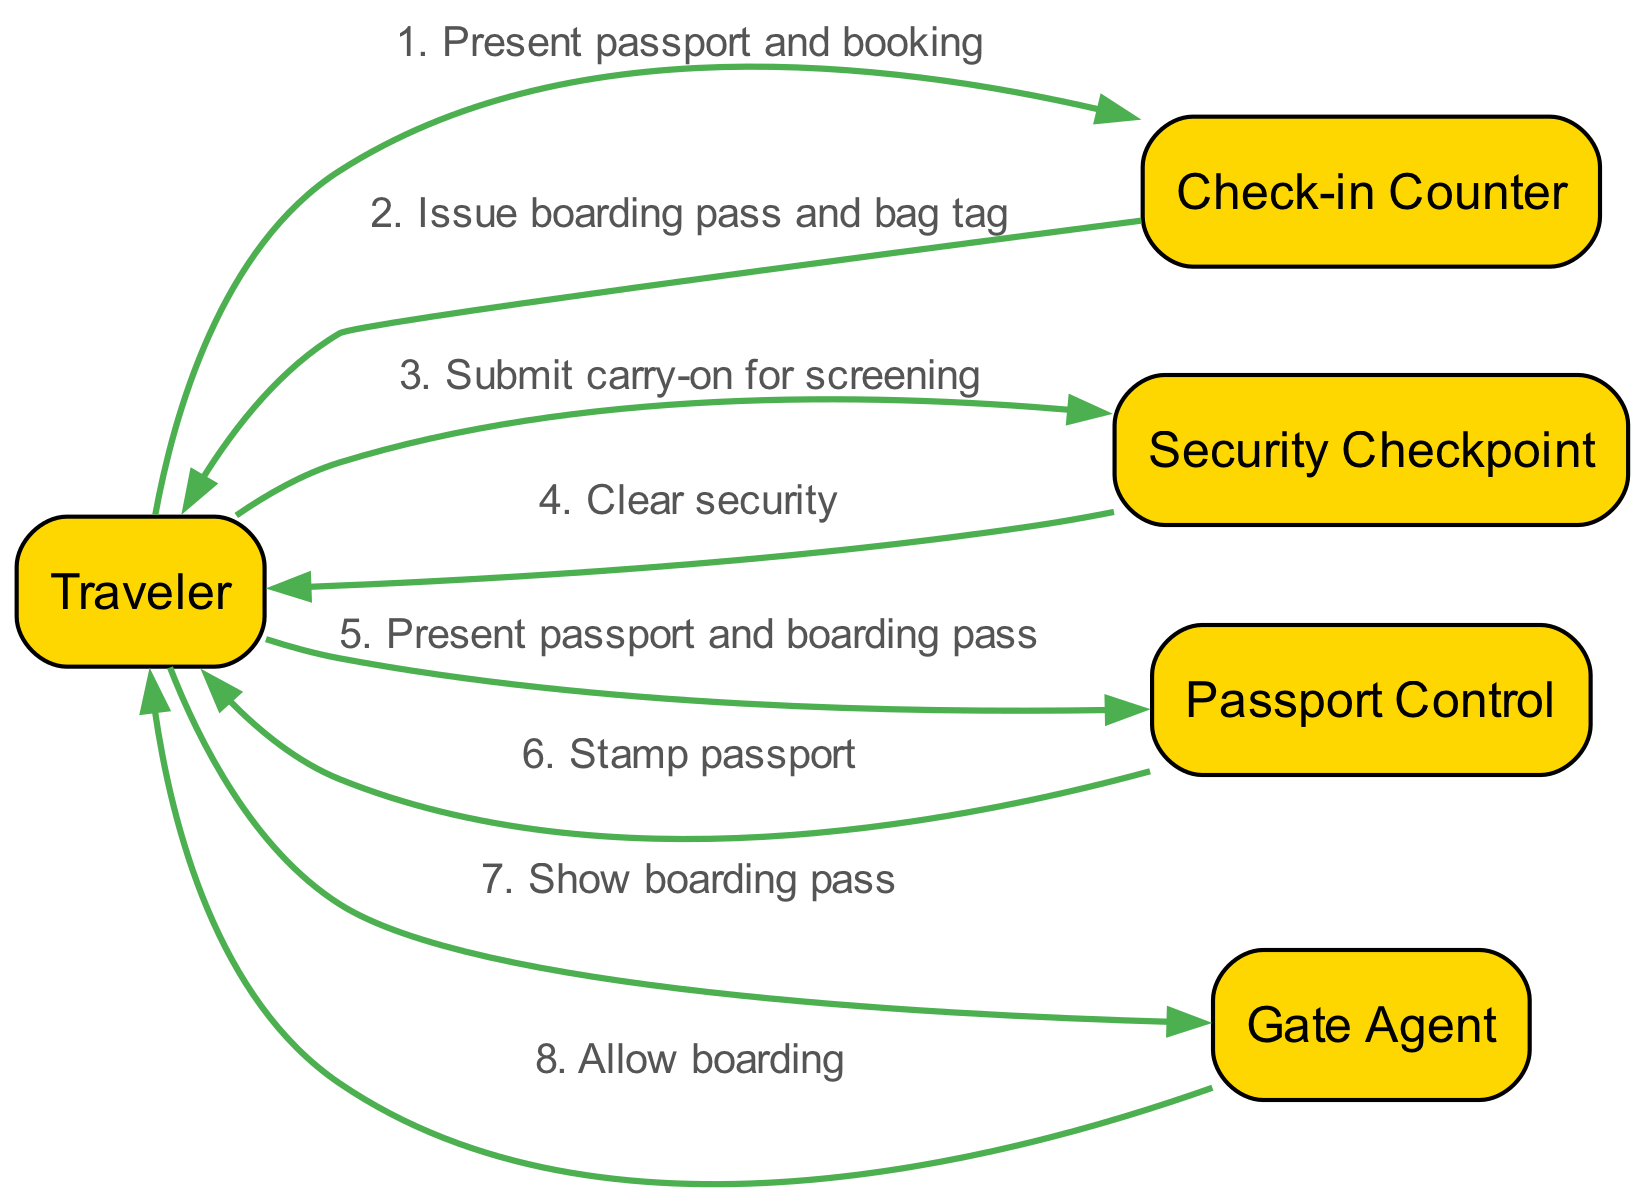What is the first action taken by the Traveler? The first action involves the Traveler presenting their passport and booking to the Check-in Counter, as indicated at the beginning of the sequence.
Answer: Present passport and booking How many actors are involved in the check-in and boarding sequence? The sequence diagram includes five distinct actors: Traveler, Check-in Counter, Security Checkpoint, Passport Control, and Gate Agent. By counting these, we find there are five actors involved.
Answer: Five Which actor issues the boarding pass? The Check-in Counter issues the boarding pass to the Traveler, making it clear from the second step of the sequence that this is the actor responsible for this action.
Answer: Check-in Counter What action follows the submission of the carry-on for screening? After the Traveler submits their carry-on for screening at the Security Checkpoint, the following action is the Traveler clearing security, which is the next step in the sequence.
Answer: Clear security What is the last action taken by the Traveler before boarding? Before boarding, the Traveler shows their boarding pass to the Gate Agent. This action is listed as the second-to-last step in the sequence prior to the boarding itself.
Answer: Show boarding pass Which actor stamps the passport? The Passport Control is responsible for stamping the Traveler's passport, as noted in the sequence where the Traveler presents their passport and boarding pass. This is specifically stated as an action taken by Passport Control.
Answer: Passport Control What comes immediately after the Traveler clears security? Immediately after the Traveler clears security, they proceed to the Passport Control where they present their passport and boarding pass. This transitions smoothly to the next action indicated in the sequence.
Answer: Present passport and boarding pass How many total actions occur in the sequence? The sequence outlines eight distinct actions from its initiation at the Check-in Counter to the final boarding approval by the Gate Agent. By counting each action, we determine there are eight total actions in the sequence.
Answer: Eight 